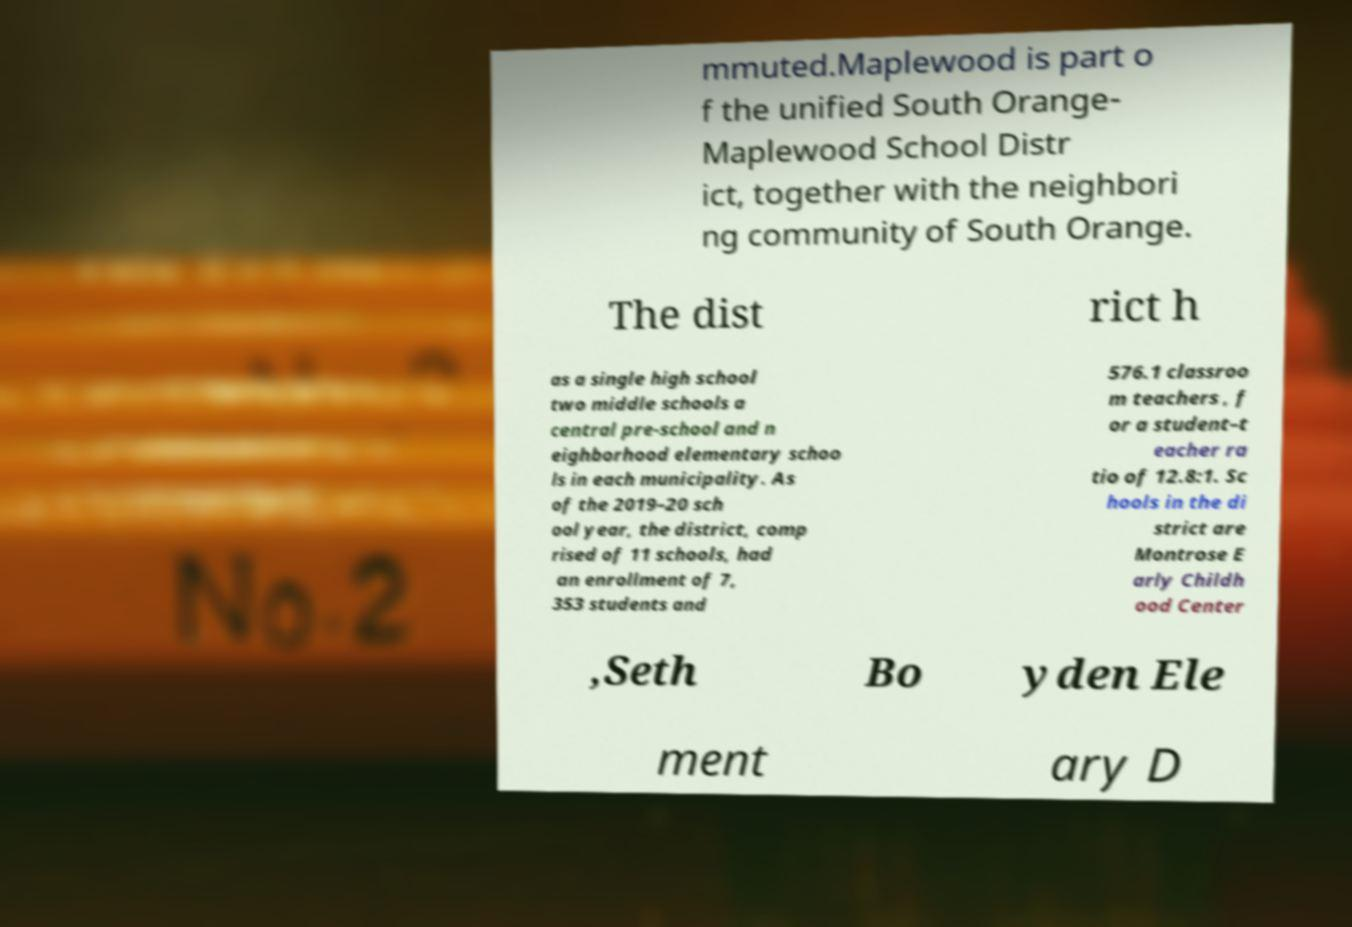Could you assist in decoding the text presented in this image and type it out clearly? mmuted.Maplewood is part o f the unified South Orange- Maplewood School Distr ict, together with the neighbori ng community of South Orange. The dist rict h as a single high school two middle schools a central pre-school and n eighborhood elementary schoo ls in each municipality. As of the 2019–20 sch ool year, the district, comp rised of 11 schools, had an enrollment of 7, 353 students and 576.1 classroo m teachers , f or a student–t eacher ra tio of 12.8:1. Sc hools in the di strict are Montrose E arly Childh ood Center ,Seth Bo yden Ele ment ary D 